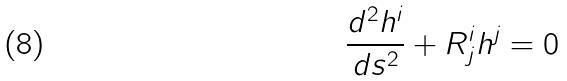Convert formula to latex. <formula><loc_0><loc_0><loc_500><loc_500>\frac { d ^ { 2 } h ^ { i } } { d s ^ { 2 } } + R _ { j } ^ { i } h ^ { j } = 0</formula> 